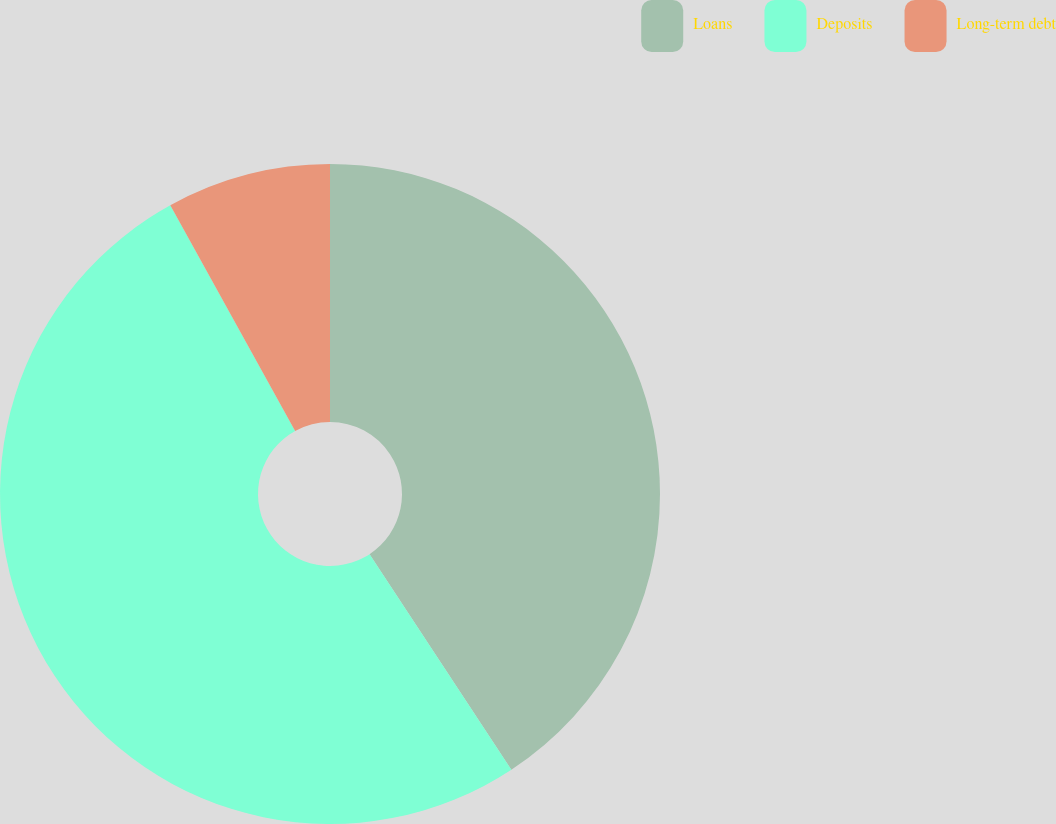Convert chart. <chart><loc_0><loc_0><loc_500><loc_500><pie_chart><fcel>Loans<fcel>Deposits<fcel>Long-term debt<nl><fcel>40.74%<fcel>51.22%<fcel>8.04%<nl></chart> 